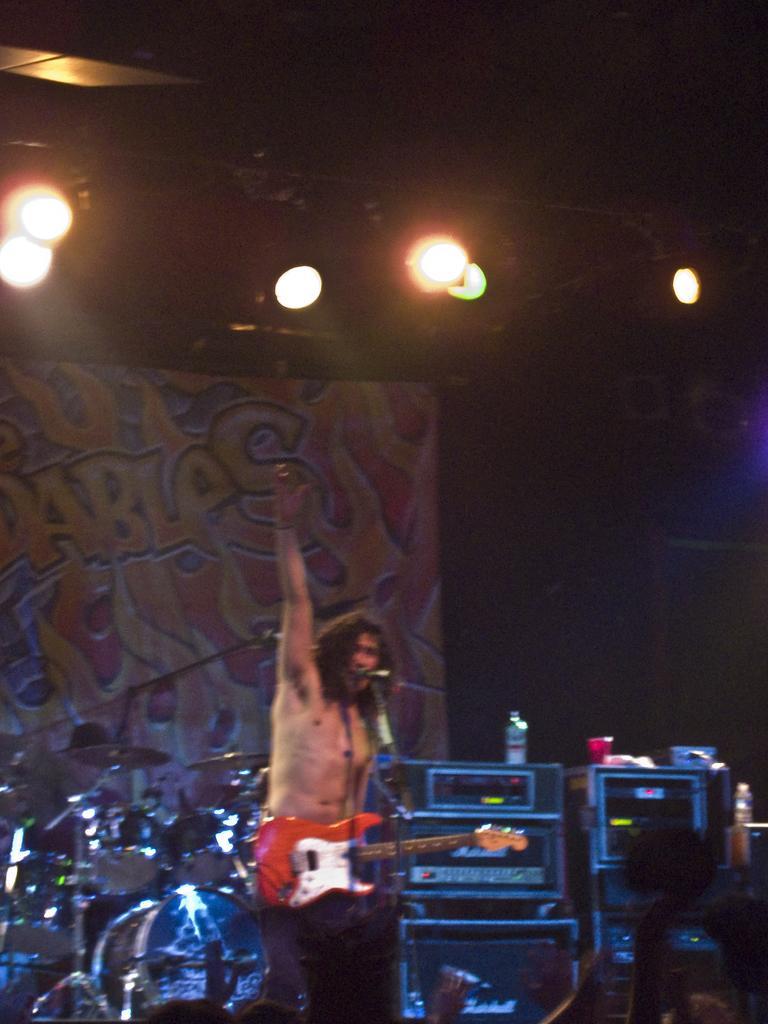Describe this image in one or two sentences. There is a man standing at the center and he is holding a guitar in his hand and he is singing on a microphone. In the background there is a drum arrangement. At the top there is a lighting arrangement. 